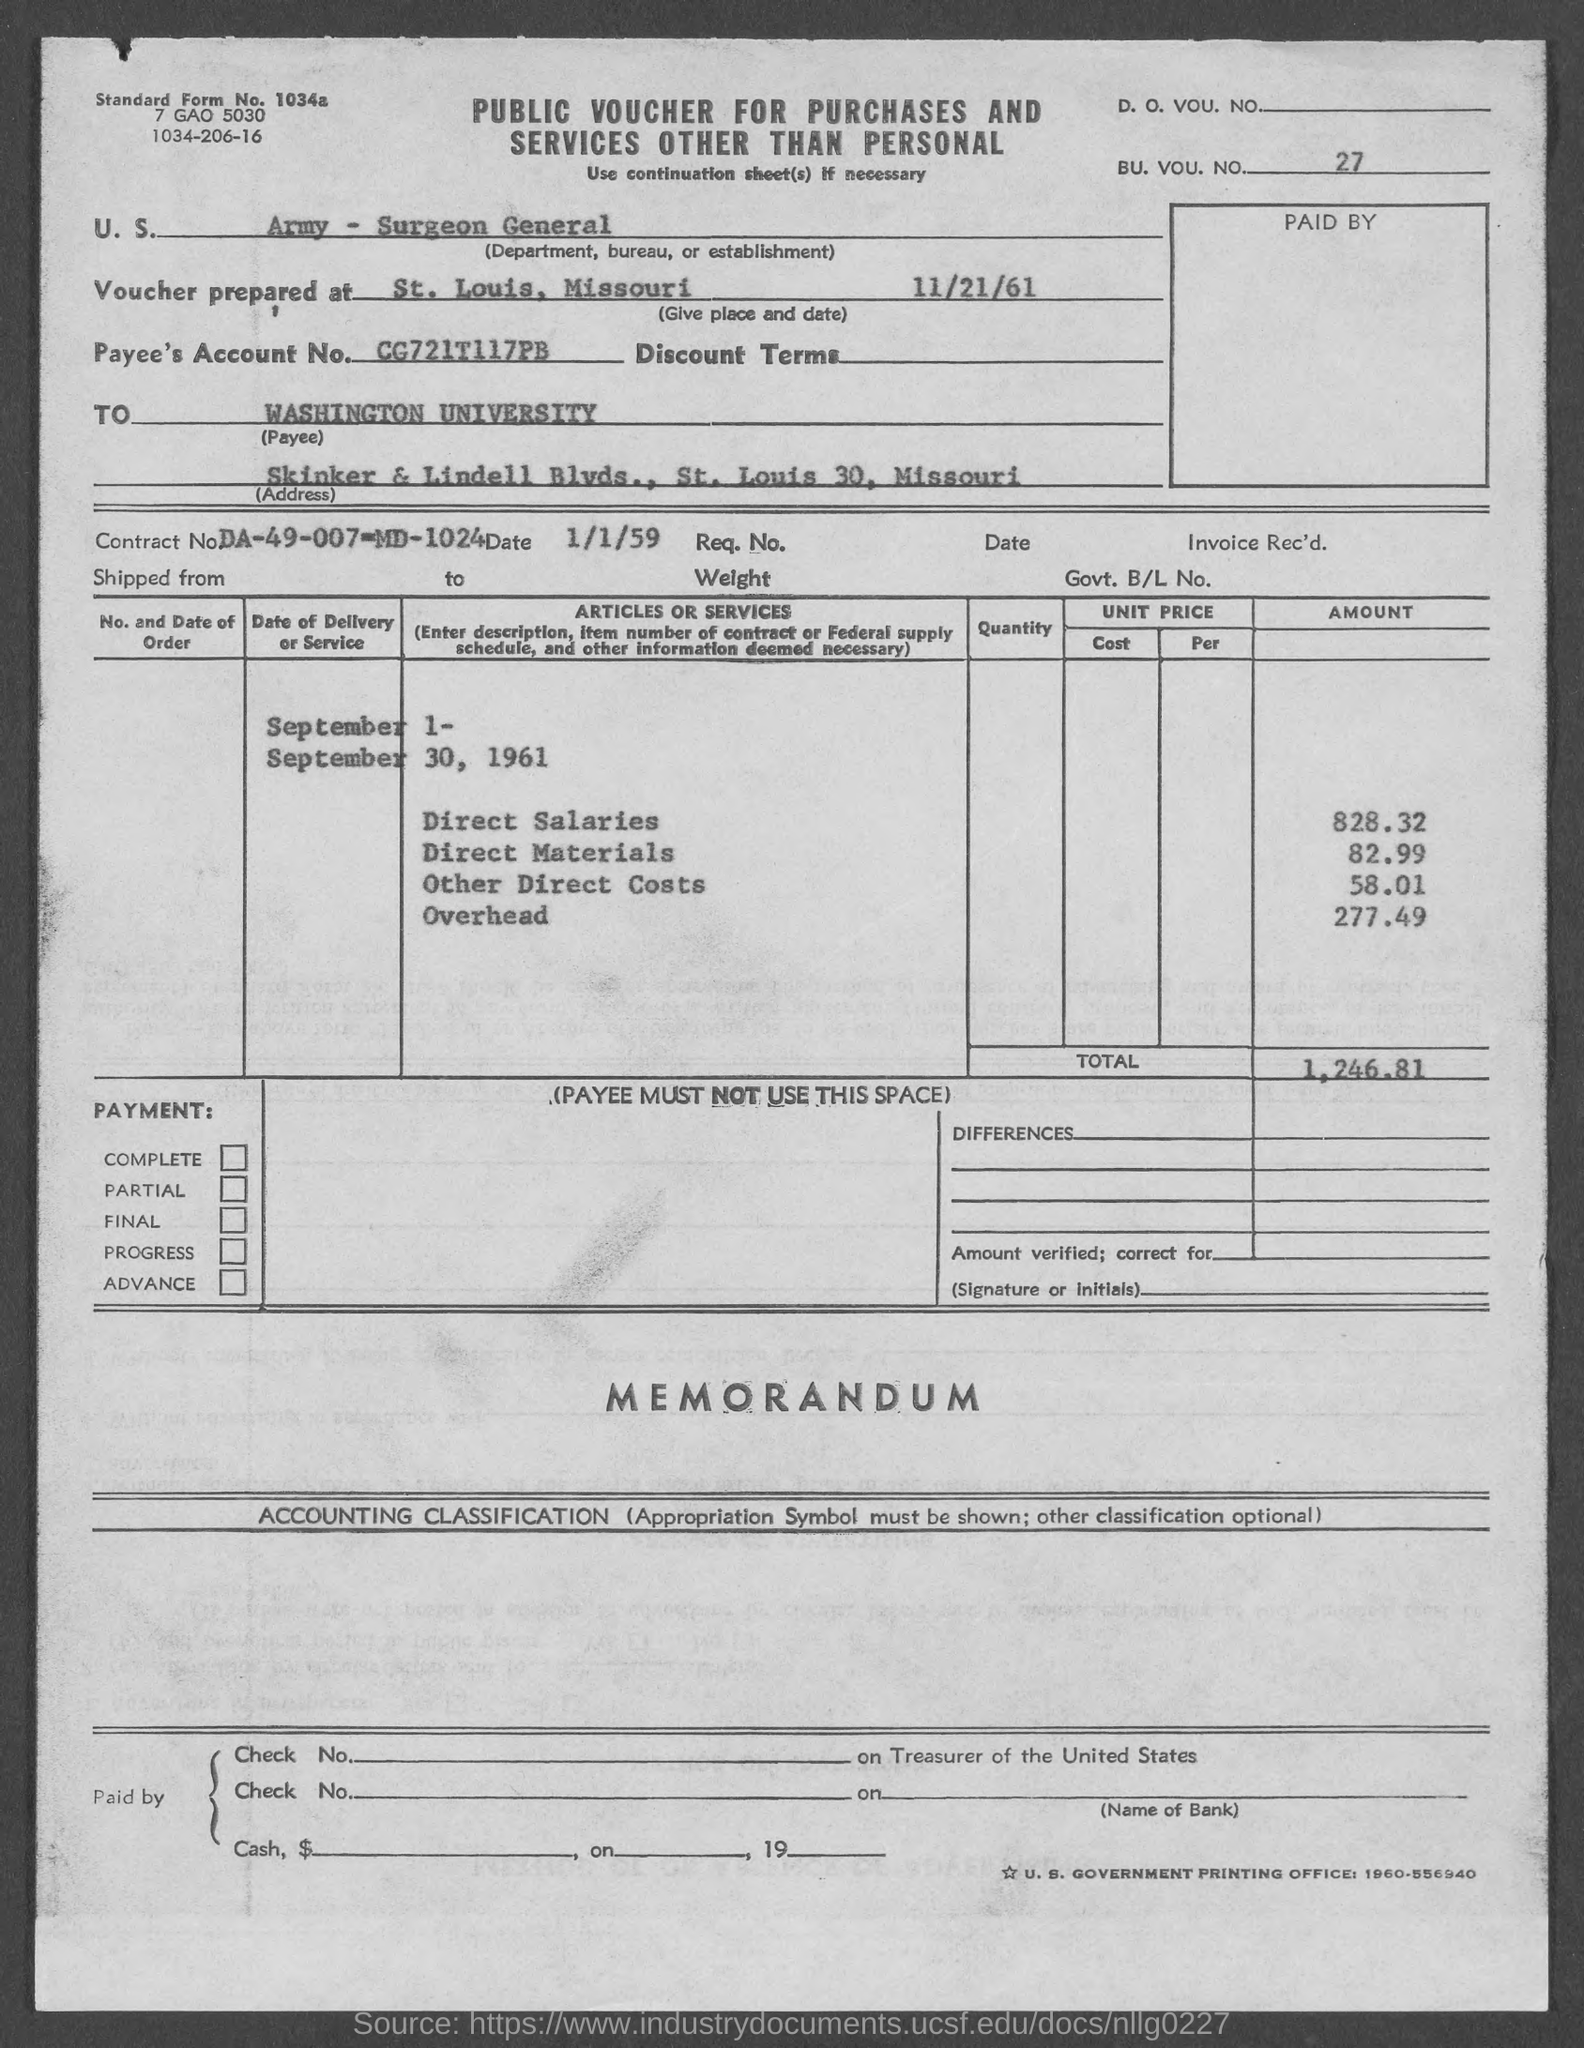What is the total overhead cost shown on this voucher? The overhead cost noted on the voucher is $277.49. 